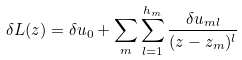<formula> <loc_0><loc_0><loc_500><loc_500>\delta L ( z ) = \delta u _ { 0 } + \sum _ { m } \sum _ { l = 1 } ^ { h _ { m } } \frac { \delta u _ { m l } } { ( z - z _ { m } ) ^ { l } }</formula> 